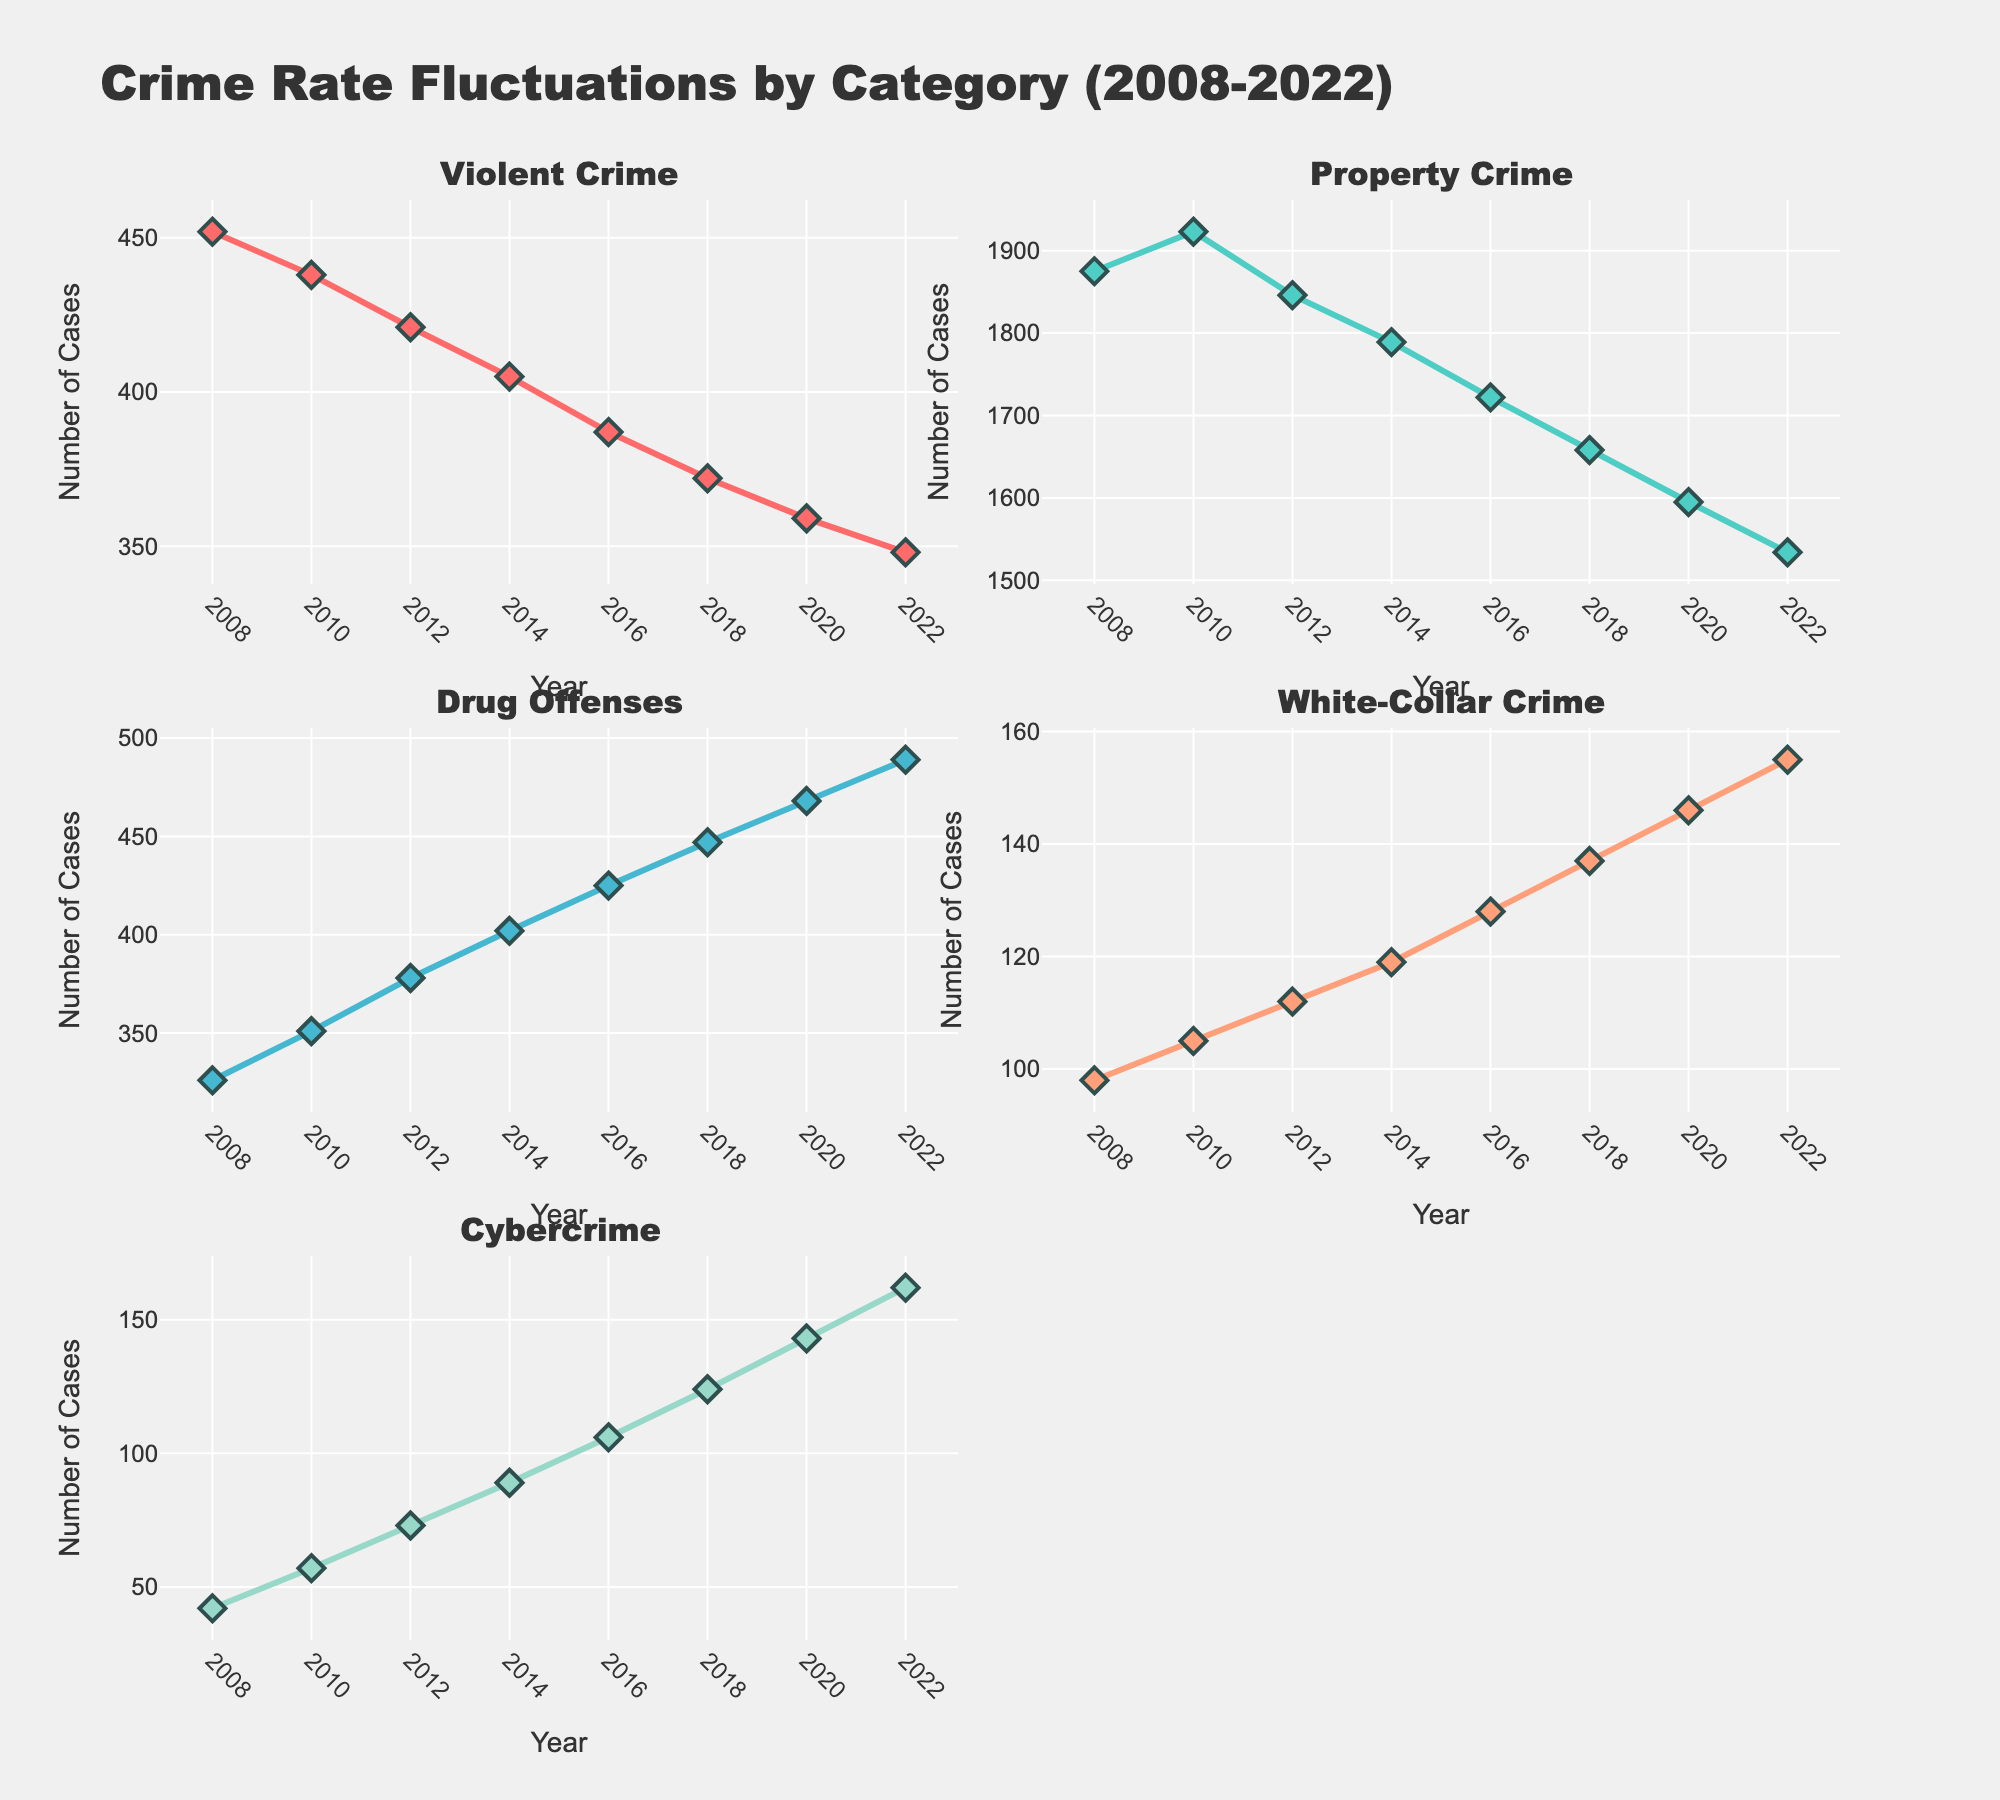how many years are displayed on the X-axis? To find the number of years displayed, we look at the horizontal X-axis of each subplot in the figure, which ranges from 2008 to 2022. Counting the intervals (2008, 2010, 2012, 2014, 2016, 2018, 2020, 2022), we have 8 years.
Answer: 8 what is the average number of Violent Crimes reported per year? To calculate the average, sum the values reported each year for Violent Crime: 452 + 438 + 421 + 405 + 387 + 372 + 359 + 348 = 3182, then divide by the number of years, which is 8. So, the average is 3182 / 8 = 397.75.
Answer: 397.75 which crime category has the steepest increase over the years? To determine the category with the steepest increase, observe the slopes of each line across the years. Cybercrime shows a clear increasing trend, starting from 42 in 2008 to 162 in 2022, which is an increase of 120 cases. Other categories either decrease or have a smaller increase.
Answer: Cybercrime which year shows the highest number of Property Crimes? To find this, look at the Property Crime line. It peaks in 2010 with a value of 1923 cases, which is the maximum number observed over all years.
Answer: 2010 how did White-Collar Crime change from 2008 to 2022? To determine the change in White-Collar Crime, subtract the value in 2008 from that in 2022. White-Collar Crime in 2008: 98, in 2022: 155. Therefore, the change is 155 - 98 = 57.
Answer: 57 which two categories show a consistent downward trend? To identify this, observe each line plot for consistent drop over the years. Both Violent Crime and Property Crime display a consistent downward trend from 2008 to 2022.
Answer: Violent Crime and Property Crime what is the combined total of all Cybercrime cases from 2008 to 2022? To find the combined total, sum all the yearly values for Cybercrime: 42 + 57 + 73 + 89 + 106 + 124 + 143 + 162 = 796.
Answer: 796 